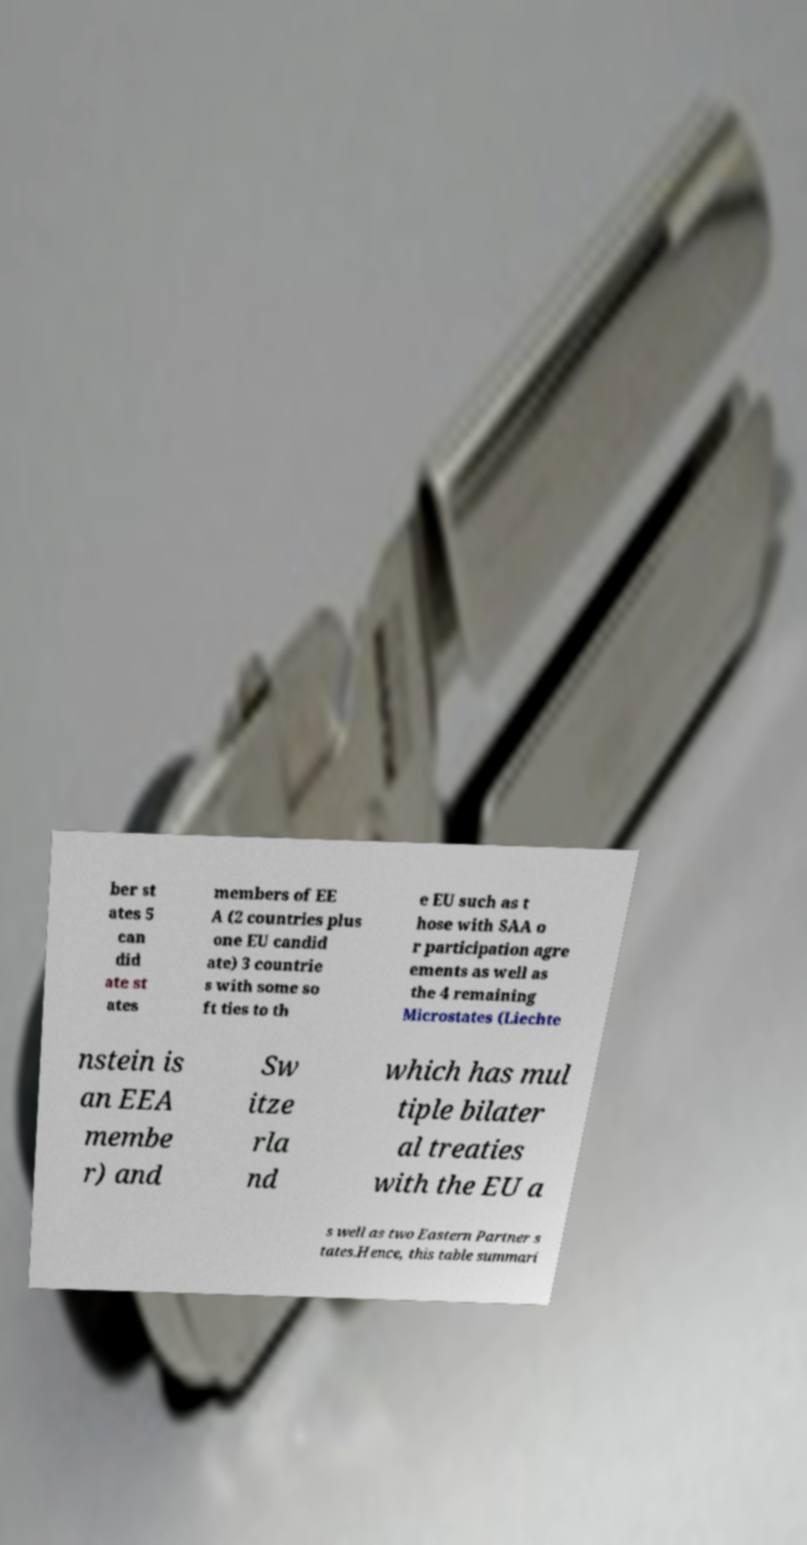Please identify and transcribe the text found in this image. ber st ates 5 can did ate st ates members of EE A (2 countries plus one EU candid ate) 3 countrie s with some so ft ties to th e EU such as t hose with SAA o r participation agre ements as well as the 4 remaining Microstates (Liechte nstein is an EEA membe r) and Sw itze rla nd which has mul tiple bilater al treaties with the EU a s well as two Eastern Partner s tates.Hence, this table summari 